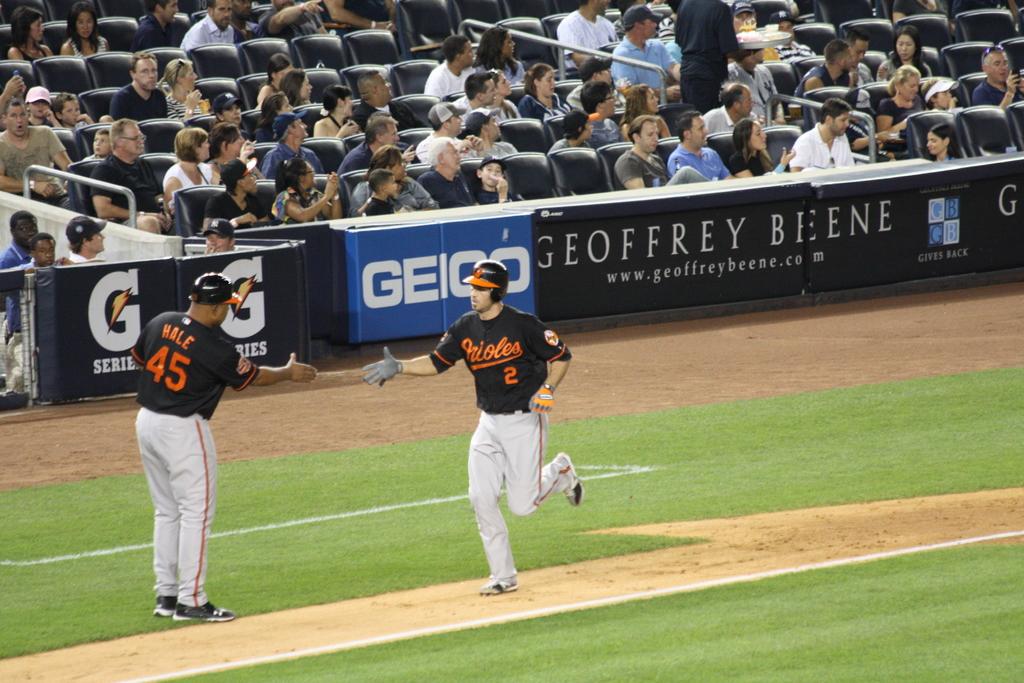Who are the sponsors on the wall?
Keep it short and to the point. Geico. What letter comes after the g?
Your answer should be very brief. E. 